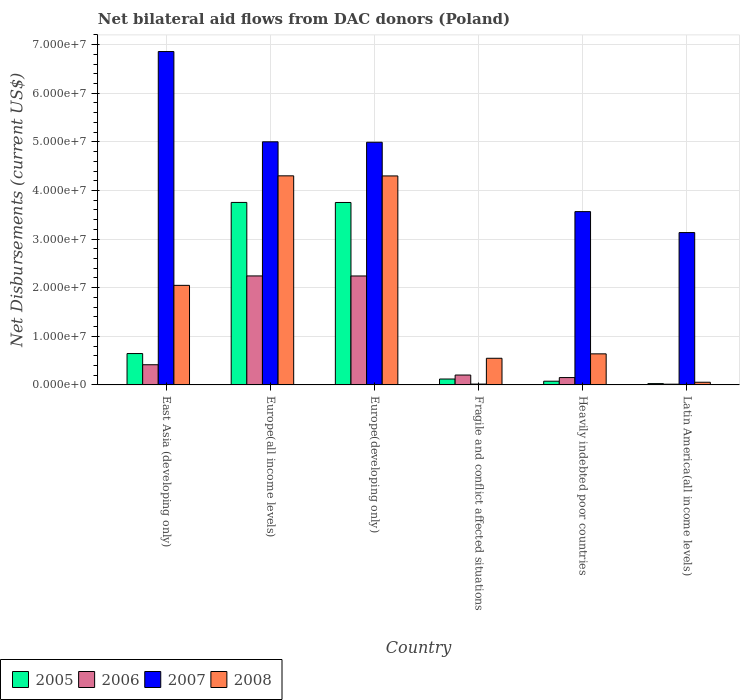How many bars are there on the 3rd tick from the left?
Offer a terse response. 4. What is the label of the 4th group of bars from the left?
Your response must be concise. Fragile and conflict affected situations. What is the net bilateral aid flows in 2006 in Europe(all income levels)?
Provide a succinct answer. 2.24e+07. Across all countries, what is the maximum net bilateral aid flows in 2005?
Your response must be concise. 3.75e+07. In which country was the net bilateral aid flows in 2008 maximum?
Keep it short and to the point. Europe(all income levels). In which country was the net bilateral aid flows in 2007 minimum?
Make the answer very short. Fragile and conflict affected situations. What is the total net bilateral aid flows in 2007 in the graph?
Provide a succinct answer. 2.36e+08. What is the difference between the net bilateral aid flows in 2006 in East Asia (developing only) and the net bilateral aid flows in 2005 in Europe(all income levels)?
Give a very brief answer. -3.34e+07. What is the average net bilateral aid flows in 2008 per country?
Your answer should be very brief. 1.98e+07. What is the ratio of the net bilateral aid flows in 2006 in Heavily indebted poor countries to that in Latin America(all income levels)?
Make the answer very short. 10.07. What is the difference between the highest and the second highest net bilateral aid flows in 2005?
Provide a short and direct response. 3.11e+07. What is the difference between the highest and the lowest net bilateral aid flows in 2006?
Your answer should be compact. 2.23e+07. In how many countries, is the net bilateral aid flows in 2008 greater than the average net bilateral aid flows in 2008 taken over all countries?
Make the answer very short. 3. Is the sum of the net bilateral aid flows in 2008 in Europe(all income levels) and Fragile and conflict affected situations greater than the maximum net bilateral aid flows in 2005 across all countries?
Ensure brevity in your answer.  Yes. What does the 4th bar from the left in Heavily indebted poor countries represents?
Ensure brevity in your answer.  2008. How many bars are there?
Your answer should be compact. 24. Are all the bars in the graph horizontal?
Make the answer very short. No. How many countries are there in the graph?
Keep it short and to the point. 6. What is the difference between two consecutive major ticks on the Y-axis?
Your response must be concise. 1.00e+07. How many legend labels are there?
Give a very brief answer. 4. How are the legend labels stacked?
Make the answer very short. Horizontal. What is the title of the graph?
Provide a succinct answer. Net bilateral aid flows from DAC donors (Poland). Does "1993" appear as one of the legend labels in the graph?
Provide a succinct answer. No. What is the label or title of the X-axis?
Your answer should be very brief. Country. What is the label or title of the Y-axis?
Your answer should be compact. Net Disbursements (current US$). What is the Net Disbursements (current US$) of 2005 in East Asia (developing only)?
Offer a very short reply. 6.45e+06. What is the Net Disbursements (current US$) in 2006 in East Asia (developing only)?
Your answer should be compact. 4.15e+06. What is the Net Disbursements (current US$) of 2007 in East Asia (developing only)?
Your response must be concise. 6.86e+07. What is the Net Disbursements (current US$) of 2008 in East Asia (developing only)?
Your answer should be very brief. 2.05e+07. What is the Net Disbursements (current US$) of 2005 in Europe(all income levels)?
Your answer should be compact. 3.75e+07. What is the Net Disbursements (current US$) in 2006 in Europe(all income levels)?
Offer a very short reply. 2.24e+07. What is the Net Disbursements (current US$) of 2007 in Europe(all income levels)?
Provide a short and direct response. 5.00e+07. What is the Net Disbursements (current US$) in 2008 in Europe(all income levels)?
Ensure brevity in your answer.  4.30e+07. What is the Net Disbursements (current US$) of 2005 in Europe(developing only)?
Make the answer very short. 3.75e+07. What is the Net Disbursements (current US$) of 2006 in Europe(developing only)?
Ensure brevity in your answer.  2.24e+07. What is the Net Disbursements (current US$) in 2007 in Europe(developing only)?
Your answer should be very brief. 4.99e+07. What is the Net Disbursements (current US$) of 2008 in Europe(developing only)?
Your answer should be compact. 4.30e+07. What is the Net Disbursements (current US$) in 2005 in Fragile and conflict affected situations?
Give a very brief answer. 1.21e+06. What is the Net Disbursements (current US$) in 2006 in Fragile and conflict affected situations?
Offer a terse response. 2.03e+06. What is the Net Disbursements (current US$) of 2008 in Fragile and conflict affected situations?
Offer a terse response. 5.48e+06. What is the Net Disbursements (current US$) in 2005 in Heavily indebted poor countries?
Keep it short and to the point. 7.60e+05. What is the Net Disbursements (current US$) in 2006 in Heavily indebted poor countries?
Give a very brief answer. 1.51e+06. What is the Net Disbursements (current US$) in 2007 in Heavily indebted poor countries?
Keep it short and to the point. 3.56e+07. What is the Net Disbursements (current US$) in 2008 in Heavily indebted poor countries?
Make the answer very short. 6.39e+06. What is the Net Disbursements (current US$) in 2007 in Latin America(all income levels)?
Your answer should be compact. 3.13e+07. Across all countries, what is the maximum Net Disbursements (current US$) of 2005?
Ensure brevity in your answer.  3.75e+07. Across all countries, what is the maximum Net Disbursements (current US$) of 2006?
Offer a terse response. 2.24e+07. Across all countries, what is the maximum Net Disbursements (current US$) of 2007?
Offer a very short reply. 6.86e+07. Across all countries, what is the maximum Net Disbursements (current US$) in 2008?
Provide a succinct answer. 4.30e+07. Across all countries, what is the minimum Net Disbursements (current US$) of 2005?
Provide a succinct answer. 2.70e+05. Across all countries, what is the minimum Net Disbursements (current US$) of 2008?
Offer a very short reply. 5.50e+05. What is the total Net Disbursements (current US$) in 2005 in the graph?
Offer a terse response. 8.38e+07. What is the total Net Disbursements (current US$) in 2006 in the graph?
Your response must be concise. 5.27e+07. What is the total Net Disbursements (current US$) of 2007 in the graph?
Your answer should be very brief. 2.36e+08. What is the total Net Disbursements (current US$) in 2008 in the graph?
Offer a terse response. 1.19e+08. What is the difference between the Net Disbursements (current US$) of 2005 in East Asia (developing only) and that in Europe(all income levels)?
Your answer should be very brief. -3.11e+07. What is the difference between the Net Disbursements (current US$) of 2006 in East Asia (developing only) and that in Europe(all income levels)?
Your answer should be compact. -1.83e+07. What is the difference between the Net Disbursements (current US$) in 2007 in East Asia (developing only) and that in Europe(all income levels)?
Provide a succinct answer. 1.86e+07. What is the difference between the Net Disbursements (current US$) in 2008 in East Asia (developing only) and that in Europe(all income levels)?
Give a very brief answer. -2.25e+07. What is the difference between the Net Disbursements (current US$) in 2005 in East Asia (developing only) and that in Europe(developing only)?
Your answer should be compact. -3.11e+07. What is the difference between the Net Disbursements (current US$) in 2006 in East Asia (developing only) and that in Europe(developing only)?
Keep it short and to the point. -1.83e+07. What is the difference between the Net Disbursements (current US$) in 2007 in East Asia (developing only) and that in Europe(developing only)?
Your answer should be very brief. 1.87e+07. What is the difference between the Net Disbursements (current US$) in 2008 in East Asia (developing only) and that in Europe(developing only)?
Make the answer very short. -2.25e+07. What is the difference between the Net Disbursements (current US$) in 2005 in East Asia (developing only) and that in Fragile and conflict affected situations?
Provide a succinct answer. 5.24e+06. What is the difference between the Net Disbursements (current US$) in 2006 in East Asia (developing only) and that in Fragile and conflict affected situations?
Ensure brevity in your answer.  2.12e+06. What is the difference between the Net Disbursements (current US$) of 2007 in East Asia (developing only) and that in Fragile and conflict affected situations?
Keep it short and to the point. 6.84e+07. What is the difference between the Net Disbursements (current US$) in 2008 in East Asia (developing only) and that in Fragile and conflict affected situations?
Your answer should be very brief. 1.50e+07. What is the difference between the Net Disbursements (current US$) in 2005 in East Asia (developing only) and that in Heavily indebted poor countries?
Provide a short and direct response. 5.69e+06. What is the difference between the Net Disbursements (current US$) in 2006 in East Asia (developing only) and that in Heavily indebted poor countries?
Give a very brief answer. 2.64e+06. What is the difference between the Net Disbursements (current US$) in 2007 in East Asia (developing only) and that in Heavily indebted poor countries?
Your answer should be compact. 3.29e+07. What is the difference between the Net Disbursements (current US$) in 2008 in East Asia (developing only) and that in Heavily indebted poor countries?
Keep it short and to the point. 1.41e+07. What is the difference between the Net Disbursements (current US$) of 2005 in East Asia (developing only) and that in Latin America(all income levels)?
Provide a short and direct response. 6.18e+06. What is the difference between the Net Disbursements (current US$) of 2007 in East Asia (developing only) and that in Latin America(all income levels)?
Ensure brevity in your answer.  3.72e+07. What is the difference between the Net Disbursements (current US$) of 2008 in East Asia (developing only) and that in Latin America(all income levels)?
Offer a terse response. 1.99e+07. What is the difference between the Net Disbursements (current US$) in 2006 in Europe(all income levels) and that in Europe(developing only)?
Ensure brevity in your answer.  10000. What is the difference between the Net Disbursements (current US$) of 2007 in Europe(all income levels) and that in Europe(developing only)?
Your answer should be compact. 9.00e+04. What is the difference between the Net Disbursements (current US$) of 2005 in Europe(all income levels) and that in Fragile and conflict affected situations?
Ensure brevity in your answer.  3.63e+07. What is the difference between the Net Disbursements (current US$) in 2006 in Europe(all income levels) and that in Fragile and conflict affected situations?
Your answer should be very brief. 2.04e+07. What is the difference between the Net Disbursements (current US$) in 2007 in Europe(all income levels) and that in Fragile and conflict affected situations?
Your answer should be compact. 4.98e+07. What is the difference between the Net Disbursements (current US$) in 2008 in Europe(all income levels) and that in Fragile and conflict affected situations?
Your answer should be compact. 3.75e+07. What is the difference between the Net Disbursements (current US$) of 2005 in Europe(all income levels) and that in Heavily indebted poor countries?
Offer a very short reply. 3.68e+07. What is the difference between the Net Disbursements (current US$) in 2006 in Europe(all income levels) and that in Heavily indebted poor countries?
Ensure brevity in your answer.  2.09e+07. What is the difference between the Net Disbursements (current US$) of 2007 in Europe(all income levels) and that in Heavily indebted poor countries?
Provide a succinct answer. 1.44e+07. What is the difference between the Net Disbursements (current US$) in 2008 in Europe(all income levels) and that in Heavily indebted poor countries?
Make the answer very short. 3.66e+07. What is the difference between the Net Disbursements (current US$) of 2005 in Europe(all income levels) and that in Latin America(all income levels)?
Keep it short and to the point. 3.73e+07. What is the difference between the Net Disbursements (current US$) in 2006 in Europe(all income levels) and that in Latin America(all income levels)?
Your response must be concise. 2.23e+07. What is the difference between the Net Disbursements (current US$) of 2007 in Europe(all income levels) and that in Latin America(all income levels)?
Give a very brief answer. 1.87e+07. What is the difference between the Net Disbursements (current US$) of 2008 in Europe(all income levels) and that in Latin America(all income levels)?
Ensure brevity in your answer.  4.25e+07. What is the difference between the Net Disbursements (current US$) of 2005 in Europe(developing only) and that in Fragile and conflict affected situations?
Provide a succinct answer. 3.63e+07. What is the difference between the Net Disbursements (current US$) in 2006 in Europe(developing only) and that in Fragile and conflict affected situations?
Your answer should be very brief. 2.04e+07. What is the difference between the Net Disbursements (current US$) of 2007 in Europe(developing only) and that in Fragile and conflict affected situations?
Provide a short and direct response. 4.98e+07. What is the difference between the Net Disbursements (current US$) of 2008 in Europe(developing only) and that in Fragile and conflict affected situations?
Provide a short and direct response. 3.75e+07. What is the difference between the Net Disbursements (current US$) of 2005 in Europe(developing only) and that in Heavily indebted poor countries?
Your answer should be compact. 3.68e+07. What is the difference between the Net Disbursements (current US$) in 2006 in Europe(developing only) and that in Heavily indebted poor countries?
Your response must be concise. 2.09e+07. What is the difference between the Net Disbursements (current US$) of 2007 in Europe(developing only) and that in Heavily indebted poor countries?
Your answer should be very brief. 1.43e+07. What is the difference between the Net Disbursements (current US$) in 2008 in Europe(developing only) and that in Heavily indebted poor countries?
Ensure brevity in your answer.  3.66e+07. What is the difference between the Net Disbursements (current US$) of 2005 in Europe(developing only) and that in Latin America(all income levels)?
Keep it short and to the point. 3.73e+07. What is the difference between the Net Disbursements (current US$) of 2006 in Europe(developing only) and that in Latin America(all income levels)?
Offer a terse response. 2.23e+07. What is the difference between the Net Disbursements (current US$) of 2007 in Europe(developing only) and that in Latin America(all income levels)?
Offer a very short reply. 1.86e+07. What is the difference between the Net Disbursements (current US$) in 2008 in Europe(developing only) and that in Latin America(all income levels)?
Keep it short and to the point. 4.24e+07. What is the difference between the Net Disbursements (current US$) of 2005 in Fragile and conflict affected situations and that in Heavily indebted poor countries?
Offer a very short reply. 4.50e+05. What is the difference between the Net Disbursements (current US$) of 2006 in Fragile and conflict affected situations and that in Heavily indebted poor countries?
Your response must be concise. 5.20e+05. What is the difference between the Net Disbursements (current US$) of 2007 in Fragile and conflict affected situations and that in Heavily indebted poor countries?
Your answer should be very brief. -3.55e+07. What is the difference between the Net Disbursements (current US$) of 2008 in Fragile and conflict affected situations and that in Heavily indebted poor countries?
Offer a terse response. -9.10e+05. What is the difference between the Net Disbursements (current US$) in 2005 in Fragile and conflict affected situations and that in Latin America(all income levels)?
Provide a succinct answer. 9.40e+05. What is the difference between the Net Disbursements (current US$) of 2006 in Fragile and conflict affected situations and that in Latin America(all income levels)?
Your response must be concise. 1.88e+06. What is the difference between the Net Disbursements (current US$) of 2007 in Fragile and conflict affected situations and that in Latin America(all income levels)?
Make the answer very short. -3.12e+07. What is the difference between the Net Disbursements (current US$) in 2008 in Fragile and conflict affected situations and that in Latin America(all income levels)?
Make the answer very short. 4.93e+06. What is the difference between the Net Disbursements (current US$) of 2005 in Heavily indebted poor countries and that in Latin America(all income levels)?
Offer a terse response. 4.90e+05. What is the difference between the Net Disbursements (current US$) of 2006 in Heavily indebted poor countries and that in Latin America(all income levels)?
Provide a succinct answer. 1.36e+06. What is the difference between the Net Disbursements (current US$) of 2007 in Heavily indebted poor countries and that in Latin America(all income levels)?
Offer a terse response. 4.31e+06. What is the difference between the Net Disbursements (current US$) of 2008 in Heavily indebted poor countries and that in Latin America(all income levels)?
Give a very brief answer. 5.84e+06. What is the difference between the Net Disbursements (current US$) in 2005 in East Asia (developing only) and the Net Disbursements (current US$) in 2006 in Europe(all income levels)?
Your answer should be very brief. -1.60e+07. What is the difference between the Net Disbursements (current US$) in 2005 in East Asia (developing only) and the Net Disbursements (current US$) in 2007 in Europe(all income levels)?
Keep it short and to the point. -4.36e+07. What is the difference between the Net Disbursements (current US$) of 2005 in East Asia (developing only) and the Net Disbursements (current US$) of 2008 in Europe(all income levels)?
Your answer should be compact. -3.66e+07. What is the difference between the Net Disbursements (current US$) of 2006 in East Asia (developing only) and the Net Disbursements (current US$) of 2007 in Europe(all income levels)?
Offer a terse response. -4.59e+07. What is the difference between the Net Disbursements (current US$) of 2006 in East Asia (developing only) and the Net Disbursements (current US$) of 2008 in Europe(all income levels)?
Your answer should be very brief. -3.89e+07. What is the difference between the Net Disbursements (current US$) in 2007 in East Asia (developing only) and the Net Disbursements (current US$) in 2008 in Europe(all income levels)?
Offer a very short reply. 2.56e+07. What is the difference between the Net Disbursements (current US$) of 2005 in East Asia (developing only) and the Net Disbursements (current US$) of 2006 in Europe(developing only)?
Offer a very short reply. -1.60e+07. What is the difference between the Net Disbursements (current US$) in 2005 in East Asia (developing only) and the Net Disbursements (current US$) in 2007 in Europe(developing only)?
Your response must be concise. -4.35e+07. What is the difference between the Net Disbursements (current US$) in 2005 in East Asia (developing only) and the Net Disbursements (current US$) in 2008 in Europe(developing only)?
Give a very brief answer. -3.65e+07. What is the difference between the Net Disbursements (current US$) in 2006 in East Asia (developing only) and the Net Disbursements (current US$) in 2007 in Europe(developing only)?
Your response must be concise. -4.58e+07. What is the difference between the Net Disbursements (current US$) of 2006 in East Asia (developing only) and the Net Disbursements (current US$) of 2008 in Europe(developing only)?
Your response must be concise. -3.88e+07. What is the difference between the Net Disbursements (current US$) of 2007 in East Asia (developing only) and the Net Disbursements (current US$) of 2008 in Europe(developing only)?
Your answer should be compact. 2.56e+07. What is the difference between the Net Disbursements (current US$) of 2005 in East Asia (developing only) and the Net Disbursements (current US$) of 2006 in Fragile and conflict affected situations?
Ensure brevity in your answer.  4.42e+06. What is the difference between the Net Disbursements (current US$) in 2005 in East Asia (developing only) and the Net Disbursements (current US$) in 2007 in Fragile and conflict affected situations?
Your response must be concise. 6.28e+06. What is the difference between the Net Disbursements (current US$) in 2005 in East Asia (developing only) and the Net Disbursements (current US$) in 2008 in Fragile and conflict affected situations?
Provide a succinct answer. 9.70e+05. What is the difference between the Net Disbursements (current US$) of 2006 in East Asia (developing only) and the Net Disbursements (current US$) of 2007 in Fragile and conflict affected situations?
Provide a short and direct response. 3.98e+06. What is the difference between the Net Disbursements (current US$) in 2006 in East Asia (developing only) and the Net Disbursements (current US$) in 2008 in Fragile and conflict affected situations?
Give a very brief answer. -1.33e+06. What is the difference between the Net Disbursements (current US$) in 2007 in East Asia (developing only) and the Net Disbursements (current US$) in 2008 in Fragile and conflict affected situations?
Offer a very short reply. 6.31e+07. What is the difference between the Net Disbursements (current US$) of 2005 in East Asia (developing only) and the Net Disbursements (current US$) of 2006 in Heavily indebted poor countries?
Provide a short and direct response. 4.94e+06. What is the difference between the Net Disbursements (current US$) in 2005 in East Asia (developing only) and the Net Disbursements (current US$) in 2007 in Heavily indebted poor countries?
Ensure brevity in your answer.  -2.92e+07. What is the difference between the Net Disbursements (current US$) of 2006 in East Asia (developing only) and the Net Disbursements (current US$) of 2007 in Heavily indebted poor countries?
Keep it short and to the point. -3.15e+07. What is the difference between the Net Disbursements (current US$) of 2006 in East Asia (developing only) and the Net Disbursements (current US$) of 2008 in Heavily indebted poor countries?
Make the answer very short. -2.24e+06. What is the difference between the Net Disbursements (current US$) of 2007 in East Asia (developing only) and the Net Disbursements (current US$) of 2008 in Heavily indebted poor countries?
Offer a terse response. 6.22e+07. What is the difference between the Net Disbursements (current US$) in 2005 in East Asia (developing only) and the Net Disbursements (current US$) in 2006 in Latin America(all income levels)?
Offer a very short reply. 6.30e+06. What is the difference between the Net Disbursements (current US$) of 2005 in East Asia (developing only) and the Net Disbursements (current US$) of 2007 in Latin America(all income levels)?
Give a very brief answer. -2.49e+07. What is the difference between the Net Disbursements (current US$) of 2005 in East Asia (developing only) and the Net Disbursements (current US$) of 2008 in Latin America(all income levels)?
Make the answer very short. 5.90e+06. What is the difference between the Net Disbursements (current US$) of 2006 in East Asia (developing only) and the Net Disbursements (current US$) of 2007 in Latin America(all income levels)?
Ensure brevity in your answer.  -2.72e+07. What is the difference between the Net Disbursements (current US$) of 2006 in East Asia (developing only) and the Net Disbursements (current US$) of 2008 in Latin America(all income levels)?
Provide a succinct answer. 3.60e+06. What is the difference between the Net Disbursements (current US$) of 2007 in East Asia (developing only) and the Net Disbursements (current US$) of 2008 in Latin America(all income levels)?
Your answer should be very brief. 6.80e+07. What is the difference between the Net Disbursements (current US$) in 2005 in Europe(all income levels) and the Net Disbursements (current US$) in 2006 in Europe(developing only)?
Keep it short and to the point. 1.51e+07. What is the difference between the Net Disbursements (current US$) in 2005 in Europe(all income levels) and the Net Disbursements (current US$) in 2007 in Europe(developing only)?
Keep it short and to the point. -1.24e+07. What is the difference between the Net Disbursements (current US$) of 2005 in Europe(all income levels) and the Net Disbursements (current US$) of 2008 in Europe(developing only)?
Provide a short and direct response. -5.45e+06. What is the difference between the Net Disbursements (current US$) of 2006 in Europe(all income levels) and the Net Disbursements (current US$) of 2007 in Europe(developing only)?
Offer a terse response. -2.75e+07. What is the difference between the Net Disbursements (current US$) in 2006 in Europe(all income levels) and the Net Disbursements (current US$) in 2008 in Europe(developing only)?
Your answer should be very brief. -2.06e+07. What is the difference between the Net Disbursements (current US$) of 2007 in Europe(all income levels) and the Net Disbursements (current US$) of 2008 in Europe(developing only)?
Your answer should be very brief. 7.02e+06. What is the difference between the Net Disbursements (current US$) in 2005 in Europe(all income levels) and the Net Disbursements (current US$) in 2006 in Fragile and conflict affected situations?
Offer a very short reply. 3.55e+07. What is the difference between the Net Disbursements (current US$) of 2005 in Europe(all income levels) and the Net Disbursements (current US$) of 2007 in Fragile and conflict affected situations?
Your answer should be very brief. 3.74e+07. What is the difference between the Net Disbursements (current US$) in 2005 in Europe(all income levels) and the Net Disbursements (current US$) in 2008 in Fragile and conflict affected situations?
Your response must be concise. 3.21e+07. What is the difference between the Net Disbursements (current US$) in 2006 in Europe(all income levels) and the Net Disbursements (current US$) in 2007 in Fragile and conflict affected situations?
Provide a succinct answer. 2.22e+07. What is the difference between the Net Disbursements (current US$) of 2006 in Europe(all income levels) and the Net Disbursements (current US$) of 2008 in Fragile and conflict affected situations?
Offer a terse response. 1.69e+07. What is the difference between the Net Disbursements (current US$) of 2007 in Europe(all income levels) and the Net Disbursements (current US$) of 2008 in Fragile and conflict affected situations?
Your answer should be very brief. 4.45e+07. What is the difference between the Net Disbursements (current US$) of 2005 in Europe(all income levels) and the Net Disbursements (current US$) of 2006 in Heavily indebted poor countries?
Provide a succinct answer. 3.60e+07. What is the difference between the Net Disbursements (current US$) of 2005 in Europe(all income levels) and the Net Disbursements (current US$) of 2007 in Heavily indebted poor countries?
Offer a terse response. 1.89e+06. What is the difference between the Net Disbursements (current US$) in 2005 in Europe(all income levels) and the Net Disbursements (current US$) in 2008 in Heavily indebted poor countries?
Your answer should be compact. 3.12e+07. What is the difference between the Net Disbursements (current US$) in 2006 in Europe(all income levels) and the Net Disbursements (current US$) in 2007 in Heavily indebted poor countries?
Your response must be concise. -1.32e+07. What is the difference between the Net Disbursements (current US$) of 2006 in Europe(all income levels) and the Net Disbursements (current US$) of 2008 in Heavily indebted poor countries?
Your answer should be compact. 1.60e+07. What is the difference between the Net Disbursements (current US$) of 2007 in Europe(all income levels) and the Net Disbursements (current US$) of 2008 in Heavily indebted poor countries?
Make the answer very short. 4.36e+07. What is the difference between the Net Disbursements (current US$) of 2005 in Europe(all income levels) and the Net Disbursements (current US$) of 2006 in Latin America(all income levels)?
Your response must be concise. 3.74e+07. What is the difference between the Net Disbursements (current US$) of 2005 in Europe(all income levels) and the Net Disbursements (current US$) of 2007 in Latin America(all income levels)?
Keep it short and to the point. 6.20e+06. What is the difference between the Net Disbursements (current US$) of 2005 in Europe(all income levels) and the Net Disbursements (current US$) of 2008 in Latin America(all income levels)?
Your response must be concise. 3.70e+07. What is the difference between the Net Disbursements (current US$) of 2006 in Europe(all income levels) and the Net Disbursements (current US$) of 2007 in Latin America(all income levels)?
Give a very brief answer. -8.92e+06. What is the difference between the Net Disbursements (current US$) of 2006 in Europe(all income levels) and the Net Disbursements (current US$) of 2008 in Latin America(all income levels)?
Give a very brief answer. 2.19e+07. What is the difference between the Net Disbursements (current US$) of 2007 in Europe(all income levels) and the Net Disbursements (current US$) of 2008 in Latin America(all income levels)?
Ensure brevity in your answer.  4.95e+07. What is the difference between the Net Disbursements (current US$) in 2005 in Europe(developing only) and the Net Disbursements (current US$) in 2006 in Fragile and conflict affected situations?
Make the answer very short. 3.55e+07. What is the difference between the Net Disbursements (current US$) in 2005 in Europe(developing only) and the Net Disbursements (current US$) in 2007 in Fragile and conflict affected situations?
Your answer should be very brief. 3.74e+07. What is the difference between the Net Disbursements (current US$) in 2005 in Europe(developing only) and the Net Disbursements (current US$) in 2008 in Fragile and conflict affected situations?
Make the answer very short. 3.20e+07. What is the difference between the Net Disbursements (current US$) of 2006 in Europe(developing only) and the Net Disbursements (current US$) of 2007 in Fragile and conflict affected situations?
Provide a short and direct response. 2.22e+07. What is the difference between the Net Disbursements (current US$) of 2006 in Europe(developing only) and the Net Disbursements (current US$) of 2008 in Fragile and conflict affected situations?
Make the answer very short. 1.69e+07. What is the difference between the Net Disbursements (current US$) of 2007 in Europe(developing only) and the Net Disbursements (current US$) of 2008 in Fragile and conflict affected situations?
Make the answer very short. 4.44e+07. What is the difference between the Net Disbursements (current US$) of 2005 in Europe(developing only) and the Net Disbursements (current US$) of 2006 in Heavily indebted poor countries?
Make the answer very short. 3.60e+07. What is the difference between the Net Disbursements (current US$) of 2005 in Europe(developing only) and the Net Disbursements (current US$) of 2007 in Heavily indebted poor countries?
Provide a succinct answer. 1.88e+06. What is the difference between the Net Disbursements (current US$) of 2005 in Europe(developing only) and the Net Disbursements (current US$) of 2008 in Heavily indebted poor countries?
Offer a very short reply. 3.11e+07. What is the difference between the Net Disbursements (current US$) in 2006 in Europe(developing only) and the Net Disbursements (current US$) in 2007 in Heavily indebted poor countries?
Your answer should be very brief. -1.32e+07. What is the difference between the Net Disbursements (current US$) of 2006 in Europe(developing only) and the Net Disbursements (current US$) of 2008 in Heavily indebted poor countries?
Make the answer very short. 1.60e+07. What is the difference between the Net Disbursements (current US$) in 2007 in Europe(developing only) and the Net Disbursements (current US$) in 2008 in Heavily indebted poor countries?
Keep it short and to the point. 4.35e+07. What is the difference between the Net Disbursements (current US$) in 2005 in Europe(developing only) and the Net Disbursements (current US$) in 2006 in Latin America(all income levels)?
Offer a terse response. 3.74e+07. What is the difference between the Net Disbursements (current US$) in 2005 in Europe(developing only) and the Net Disbursements (current US$) in 2007 in Latin America(all income levels)?
Provide a succinct answer. 6.19e+06. What is the difference between the Net Disbursements (current US$) in 2005 in Europe(developing only) and the Net Disbursements (current US$) in 2008 in Latin America(all income levels)?
Ensure brevity in your answer.  3.70e+07. What is the difference between the Net Disbursements (current US$) in 2006 in Europe(developing only) and the Net Disbursements (current US$) in 2007 in Latin America(all income levels)?
Your answer should be compact. -8.93e+06. What is the difference between the Net Disbursements (current US$) of 2006 in Europe(developing only) and the Net Disbursements (current US$) of 2008 in Latin America(all income levels)?
Make the answer very short. 2.19e+07. What is the difference between the Net Disbursements (current US$) of 2007 in Europe(developing only) and the Net Disbursements (current US$) of 2008 in Latin America(all income levels)?
Your answer should be compact. 4.94e+07. What is the difference between the Net Disbursements (current US$) in 2005 in Fragile and conflict affected situations and the Net Disbursements (current US$) in 2007 in Heavily indebted poor countries?
Make the answer very short. -3.44e+07. What is the difference between the Net Disbursements (current US$) of 2005 in Fragile and conflict affected situations and the Net Disbursements (current US$) of 2008 in Heavily indebted poor countries?
Your response must be concise. -5.18e+06. What is the difference between the Net Disbursements (current US$) of 2006 in Fragile and conflict affected situations and the Net Disbursements (current US$) of 2007 in Heavily indebted poor countries?
Make the answer very short. -3.36e+07. What is the difference between the Net Disbursements (current US$) in 2006 in Fragile and conflict affected situations and the Net Disbursements (current US$) in 2008 in Heavily indebted poor countries?
Your answer should be compact. -4.36e+06. What is the difference between the Net Disbursements (current US$) of 2007 in Fragile and conflict affected situations and the Net Disbursements (current US$) of 2008 in Heavily indebted poor countries?
Your answer should be compact. -6.22e+06. What is the difference between the Net Disbursements (current US$) of 2005 in Fragile and conflict affected situations and the Net Disbursements (current US$) of 2006 in Latin America(all income levels)?
Keep it short and to the point. 1.06e+06. What is the difference between the Net Disbursements (current US$) of 2005 in Fragile and conflict affected situations and the Net Disbursements (current US$) of 2007 in Latin America(all income levels)?
Offer a terse response. -3.01e+07. What is the difference between the Net Disbursements (current US$) in 2006 in Fragile and conflict affected situations and the Net Disbursements (current US$) in 2007 in Latin America(all income levels)?
Ensure brevity in your answer.  -2.93e+07. What is the difference between the Net Disbursements (current US$) of 2006 in Fragile and conflict affected situations and the Net Disbursements (current US$) of 2008 in Latin America(all income levels)?
Keep it short and to the point. 1.48e+06. What is the difference between the Net Disbursements (current US$) in 2007 in Fragile and conflict affected situations and the Net Disbursements (current US$) in 2008 in Latin America(all income levels)?
Offer a very short reply. -3.80e+05. What is the difference between the Net Disbursements (current US$) of 2005 in Heavily indebted poor countries and the Net Disbursements (current US$) of 2006 in Latin America(all income levels)?
Offer a terse response. 6.10e+05. What is the difference between the Net Disbursements (current US$) in 2005 in Heavily indebted poor countries and the Net Disbursements (current US$) in 2007 in Latin America(all income levels)?
Provide a succinct answer. -3.06e+07. What is the difference between the Net Disbursements (current US$) of 2005 in Heavily indebted poor countries and the Net Disbursements (current US$) of 2008 in Latin America(all income levels)?
Your answer should be very brief. 2.10e+05. What is the difference between the Net Disbursements (current US$) of 2006 in Heavily indebted poor countries and the Net Disbursements (current US$) of 2007 in Latin America(all income levels)?
Offer a very short reply. -2.98e+07. What is the difference between the Net Disbursements (current US$) in 2006 in Heavily indebted poor countries and the Net Disbursements (current US$) in 2008 in Latin America(all income levels)?
Ensure brevity in your answer.  9.60e+05. What is the difference between the Net Disbursements (current US$) in 2007 in Heavily indebted poor countries and the Net Disbursements (current US$) in 2008 in Latin America(all income levels)?
Provide a short and direct response. 3.51e+07. What is the average Net Disbursements (current US$) in 2005 per country?
Give a very brief answer. 1.40e+07. What is the average Net Disbursements (current US$) in 2006 per country?
Give a very brief answer. 8.78e+06. What is the average Net Disbursements (current US$) in 2007 per country?
Offer a terse response. 3.93e+07. What is the average Net Disbursements (current US$) of 2008 per country?
Your answer should be very brief. 1.98e+07. What is the difference between the Net Disbursements (current US$) of 2005 and Net Disbursements (current US$) of 2006 in East Asia (developing only)?
Keep it short and to the point. 2.30e+06. What is the difference between the Net Disbursements (current US$) in 2005 and Net Disbursements (current US$) in 2007 in East Asia (developing only)?
Your response must be concise. -6.21e+07. What is the difference between the Net Disbursements (current US$) in 2005 and Net Disbursements (current US$) in 2008 in East Asia (developing only)?
Ensure brevity in your answer.  -1.40e+07. What is the difference between the Net Disbursements (current US$) of 2006 and Net Disbursements (current US$) of 2007 in East Asia (developing only)?
Offer a very short reply. -6.44e+07. What is the difference between the Net Disbursements (current US$) of 2006 and Net Disbursements (current US$) of 2008 in East Asia (developing only)?
Provide a succinct answer. -1.63e+07. What is the difference between the Net Disbursements (current US$) of 2007 and Net Disbursements (current US$) of 2008 in East Asia (developing only)?
Offer a terse response. 4.81e+07. What is the difference between the Net Disbursements (current US$) of 2005 and Net Disbursements (current US$) of 2006 in Europe(all income levels)?
Offer a very short reply. 1.51e+07. What is the difference between the Net Disbursements (current US$) of 2005 and Net Disbursements (current US$) of 2007 in Europe(all income levels)?
Your response must be concise. -1.25e+07. What is the difference between the Net Disbursements (current US$) of 2005 and Net Disbursements (current US$) of 2008 in Europe(all income levels)?
Provide a short and direct response. -5.47e+06. What is the difference between the Net Disbursements (current US$) of 2006 and Net Disbursements (current US$) of 2007 in Europe(all income levels)?
Provide a succinct answer. -2.76e+07. What is the difference between the Net Disbursements (current US$) of 2006 and Net Disbursements (current US$) of 2008 in Europe(all income levels)?
Make the answer very short. -2.06e+07. What is the difference between the Net Disbursements (current US$) of 2007 and Net Disbursements (current US$) of 2008 in Europe(all income levels)?
Your answer should be very brief. 7.00e+06. What is the difference between the Net Disbursements (current US$) in 2005 and Net Disbursements (current US$) in 2006 in Europe(developing only)?
Your response must be concise. 1.51e+07. What is the difference between the Net Disbursements (current US$) of 2005 and Net Disbursements (current US$) of 2007 in Europe(developing only)?
Give a very brief answer. -1.24e+07. What is the difference between the Net Disbursements (current US$) of 2005 and Net Disbursements (current US$) of 2008 in Europe(developing only)?
Give a very brief answer. -5.46e+06. What is the difference between the Net Disbursements (current US$) of 2006 and Net Disbursements (current US$) of 2007 in Europe(developing only)?
Your answer should be compact. -2.75e+07. What is the difference between the Net Disbursements (current US$) in 2006 and Net Disbursements (current US$) in 2008 in Europe(developing only)?
Give a very brief answer. -2.06e+07. What is the difference between the Net Disbursements (current US$) in 2007 and Net Disbursements (current US$) in 2008 in Europe(developing only)?
Provide a short and direct response. 6.93e+06. What is the difference between the Net Disbursements (current US$) in 2005 and Net Disbursements (current US$) in 2006 in Fragile and conflict affected situations?
Provide a short and direct response. -8.20e+05. What is the difference between the Net Disbursements (current US$) in 2005 and Net Disbursements (current US$) in 2007 in Fragile and conflict affected situations?
Offer a very short reply. 1.04e+06. What is the difference between the Net Disbursements (current US$) of 2005 and Net Disbursements (current US$) of 2008 in Fragile and conflict affected situations?
Offer a terse response. -4.27e+06. What is the difference between the Net Disbursements (current US$) of 2006 and Net Disbursements (current US$) of 2007 in Fragile and conflict affected situations?
Offer a terse response. 1.86e+06. What is the difference between the Net Disbursements (current US$) of 2006 and Net Disbursements (current US$) of 2008 in Fragile and conflict affected situations?
Make the answer very short. -3.45e+06. What is the difference between the Net Disbursements (current US$) of 2007 and Net Disbursements (current US$) of 2008 in Fragile and conflict affected situations?
Your answer should be very brief. -5.31e+06. What is the difference between the Net Disbursements (current US$) of 2005 and Net Disbursements (current US$) of 2006 in Heavily indebted poor countries?
Your answer should be very brief. -7.50e+05. What is the difference between the Net Disbursements (current US$) of 2005 and Net Disbursements (current US$) of 2007 in Heavily indebted poor countries?
Give a very brief answer. -3.49e+07. What is the difference between the Net Disbursements (current US$) of 2005 and Net Disbursements (current US$) of 2008 in Heavily indebted poor countries?
Offer a terse response. -5.63e+06. What is the difference between the Net Disbursements (current US$) of 2006 and Net Disbursements (current US$) of 2007 in Heavily indebted poor countries?
Offer a very short reply. -3.41e+07. What is the difference between the Net Disbursements (current US$) of 2006 and Net Disbursements (current US$) of 2008 in Heavily indebted poor countries?
Your answer should be compact. -4.88e+06. What is the difference between the Net Disbursements (current US$) in 2007 and Net Disbursements (current US$) in 2008 in Heavily indebted poor countries?
Offer a very short reply. 2.93e+07. What is the difference between the Net Disbursements (current US$) of 2005 and Net Disbursements (current US$) of 2006 in Latin America(all income levels)?
Provide a succinct answer. 1.20e+05. What is the difference between the Net Disbursements (current US$) of 2005 and Net Disbursements (current US$) of 2007 in Latin America(all income levels)?
Offer a terse response. -3.11e+07. What is the difference between the Net Disbursements (current US$) in 2005 and Net Disbursements (current US$) in 2008 in Latin America(all income levels)?
Your response must be concise. -2.80e+05. What is the difference between the Net Disbursements (current US$) of 2006 and Net Disbursements (current US$) of 2007 in Latin America(all income levels)?
Your response must be concise. -3.12e+07. What is the difference between the Net Disbursements (current US$) in 2006 and Net Disbursements (current US$) in 2008 in Latin America(all income levels)?
Your response must be concise. -4.00e+05. What is the difference between the Net Disbursements (current US$) of 2007 and Net Disbursements (current US$) of 2008 in Latin America(all income levels)?
Give a very brief answer. 3.08e+07. What is the ratio of the Net Disbursements (current US$) of 2005 in East Asia (developing only) to that in Europe(all income levels)?
Make the answer very short. 0.17. What is the ratio of the Net Disbursements (current US$) in 2006 in East Asia (developing only) to that in Europe(all income levels)?
Provide a succinct answer. 0.19. What is the ratio of the Net Disbursements (current US$) of 2007 in East Asia (developing only) to that in Europe(all income levels)?
Ensure brevity in your answer.  1.37. What is the ratio of the Net Disbursements (current US$) of 2008 in East Asia (developing only) to that in Europe(all income levels)?
Offer a terse response. 0.48. What is the ratio of the Net Disbursements (current US$) of 2005 in East Asia (developing only) to that in Europe(developing only)?
Keep it short and to the point. 0.17. What is the ratio of the Net Disbursements (current US$) of 2006 in East Asia (developing only) to that in Europe(developing only)?
Make the answer very short. 0.19. What is the ratio of the Net Disbursements (current US$) in 2007 in East Asia (developing only) to that in Europe(developing only)?
Offer a terse response. 1.37. What is the ratio of the Net Disbursements (current US$) of 2008 in East Asia (developing only) to that in Europe(developing only)?
Ensure brevity in your answer.  0.48. What is the ratio of the Net Disbursements (current US$) in 2005 in East Asia (developing only) to that in Fragile and conflict affected situations?
Your answer should be compact. 5.33. What is the ratio of the Net Disbursements (current US$) in 2006 in East Asia (developing only) to that in Fragile and conflict affected situations?
Make the answer very short. 2.04. What is the ratio of the Net Disbursements (current US$) in 2007 in East Asia (developing only) to that in Fragile and conflict affected situations?
Your answer should be compact. 403.41. What is the ratio of the Net Disbursements (current US$) in 2008 in East Asia (developing only) to that in Fragile and conflict affected situations?
Your answer should be very brief. 3.74. What is the ratio of the Net Disbursements (current US$) in 2005 in East Asia (developing only) to that in Heavily indebted poor countries?
Your answer should be very brief. 8.49. What is the ratio of the Net Disbursements (current US$) in 2006 in East Asia (developing only) to that in Heavily indebted poor countries?
Provide a short and direct response. 2.75. What is the ratio of the Net Disbursements (current US$) of 2007 in East Asia (developing only) to that in Heavily indebted poor countries?
Provide a succinct answer. 1.92. What is the ratio of the Net Disbursements (current US$) in 2008 in East Asia (developing only) to that in Heavily indebted poor countries?
Keep it short and to the point. 3.21. What is the ratio of the Net Disbursements (current US$) of 2005 in East Asia (developing only) to that in Latin America(all income levels)?
Offer a very short reply. 23.89. What is the ratio of the Net Disbursements (current US$) in 2006 in East Asia (developing only) to that in Latin America(all income levels)?
Your response must be concise. 27.67. What is the ratio of the Net Disbursements (current US$) of 2007 in East Asia (developing only) to that in Latin America(all income levels)?
Offer a terse response. 2.19. What is the ratio of the Net Disbursements (current US$) of 2008 in East Asia (developing only) to that in Latin America(all income levels)?
Make the answer very short. 37.24. What is the ratio of the Net Disbursements (current US$) in 2005 in Europe(all income levels) to that in Europe(developing only)?
Offer a very short reply. 1. What is the ratio of the Net Disbursements (current US$) of 2007 in Europe(all income levels) to that in Europe(developing only)?
Provide a succinct answer. 1. What is the ratio of the Net Disbursements (current US$) of 2008 in Europe(all income levels) to that in Europe(developing only)?
Offer a very short reply. 1. What is the ratio of the Net Disbursements (current US$) in 2005 in Europe(all income levels) to that in Fragile and conflict affected situations?
Your response must be concise. 31.02. What is the ratio of the Net Disbursements (current US$) in 2006 in Europe(all income levels) to that in Fragile and conflict affected situations?
Offer a very short reply. 11.04. What is the ratio of the Net Disbursements (current US$) of 2007 in Europe(all income levels) to that in Fragile and conflict affected situations?
Your response must be concise. 294.18. What is the ratio of the Net Disbursements (current US$) of 2008 in Europe(all income levels) to that in Fragile and conflict affected situations?
Make the answer very short. 7.85. What is the ratio of the Net Disbursements (current US$) of 2005 in Europe(all income levels) to that in Heavily indebted poor countries?
Your answer should be very brief. 49.39. What is the ratio of the Net Disbursements (current US$) in 2006 in Europe(all income levels) to that in Heavily indebted poor countries?
Your answer should be very brief. 14.85. What is the ratio of the Net Disbursements (current US$) in 2007 in Europe(all income levels) to that in Heavily indebted poor countries?
Your answer should be compact. 1.4. What is the ratio of the Net Disbursements (current US$) in 2008 in Europe(all income levels) to that in Heavily indebted poor countries?
Your answer should be very brief. 6.73. What is the ratio of the Net Disbursements (current US$) in 2005 in Europe(all income levels) to that in Latin America(all income levels)?
Keep it short and to the point. 139.04. What is the ratio of the Net Disbursements (current US$) in 2006 in Europe(all income levels) to that in Latin America(all income levels)?
Offer a terse response. 149.47. What is the ratio of the Net Disbursements (current US$) of 2007 in Europe(all income levels) to that in Latin America(all income levels)?
Provide a short and direct response. 1.6. What is the ratio of the Net Disbursements (current US$) in 2008 in Europe(all income levels) to that in Latin America(all income levels)?
Make the answer very short. 78.2. What is the ratio of the Net Disbursements (current US$) of 2005 in Europe(developing only) to that in Fragile and conflict affected situations?
Your response must be concise. 31.02. What is the ratio of the Net Disbursements (current US$) of 2006 in Europe(developing only) to that in Fragile and conflict affected situations?
Offer a very short reply. 11.04. What is the ratio of the Net Disbursements (current US$) of 2007 in Europe(developing only) to that in Fragile and conflict affected situations?
Give a very brief answer. 293.65. What is the ratio of the Net Disbursements (current US$) in 2008 in Europe(developing only) to that in Fragile and conflict affected situations?
Provide a succinct answer. 7.84. What is the ratio of the Net Disbursements (current US$) in 2005 in Europe(developing only) to that in Heavily indebted poor countries?
Give a very brief answer. 49.38. What is the ratio of the Net Disbursements (current US$) in 2006 in Europe(developing only) to that in Heavily indebted poor countries?
Keep it short and to the point. 14.84. What is the ratio of the Net Disbursements (current US$) of 2007 in Europe(developing only) to that in Heavily indebted poor countries?
Give a very brief answer. 1.4. What is the ratio of the Net Disbursements (current US$) of 2008 in Europe(developing only) to that in Heavily indebted poor countries?
Your response must be concise. 6.73. What is the ratio of the Net Disbursements (current US$) of 2005 in Europe(developing only) to that in Latin America(all income levels)?
Keep it short and to the point. 139. What is the ratio of the Net Disbursements (current US$) in 2006 in Europe(developing only) to that in Latin America(all income levels)?
Your answer should be very brief. 149.4. What is the ratio of the Net Disbursements (current US$) in 2007 in Europe(developing only) to that in Latin America(all income levels)?
Offer a terse response. 1.59. What is the ratio of the Net Disbursements (current US$) in 2008 in Europe(developing only) to that in Latin America(all income levels)?
Your response must be concise. 78.16. What is the ratio of the Net Disbursements (current US$) in 2005 in Fragile and conflict affected situations to that in Heavily indebted poor countries?
Your answer should be very brief. 1.59. What is the ratio of the Net Disbursements (current US$) of 2006 in Fragile and conflict affected situations to that in Heavily indebted poor countries?
Your answer should be compact. 1.34. What is the ratio of the Net Disbursements (current US$) in 2007 in Fragile and conflict affected situations to that in Heavily indebted poor countries?
Provide a succinct answer. 0. What is the ratio of the Net Disbursements (current US$) of 2008 in Fragile and conflict affected situations to that in Heavily indebted poor countries?
Give a very brief answer. 0.86. What is the ratio of the Net Disbursements (current US$) of 2005 in Fragile and conflict affected situations to that in Latin America(all income levels)?
Make the answer very short. 4.48. What is the ratio of the Net Disbursements (current US$) in 2006 in Fragile and conflict affected situations to that in Latin America(all income levels)?
Your answer should be very brief. 13.53. What is the ratio of the Net Disbursements (current US$) in 2007 in Fragile and conflict affected situations to that in Latin America(all income levels)?
Keep it short and to the point. 0.01. What is the ratio of the Net Disbursements (current US$) of 2008 in Fragile and conflict affected situations to that in Latin America(all income levels)?
Ensure brevity in your answer.  9.96. What is the ratio of the Net Disbursements (current US$) in 2005 in Heavily indebted poor countries to that in Latin America(all income levels)?
Offer a terse response. 2.81. What is the ratio of the Net Disbursements (current US$) in 2006 in Heavily indebted poor countries to that in Latin America(all income levels)?
Make the answer very short. 10.07. What is the ratio of the Net Disbursements (current US$) of 2007 in Heavily indebted poor countries to that in Latin America(all income levels)?
Your response must be concise. 1.14. What is the ratio of the Net Disbursements (current US$) of 2008 in Heavily indebted poor countries to that in Latin America(all income levels)?
Your answer should be very brief. 11.62. What is the difference between the highest and the second highest Net Disbursements (current US$) in 2006?
Your answer should be compact. 10000. What is the difference between the highest and the second highest Net Disbursements (current US$) of 2007?
Provide a short and direct response. 1.86e+07. What is the difference between the highest and the lowest Net Disbursements (current US$) of 2005?
Keep it short and to the point. 3.73e+07. What is the difference between the highest and the lowest Net Disbursements (current US$) in 2006?
Provide a short and direct response. 2.23e+07. What is the difference between the highest and the lowest Net Disbursements (current US$) of 2007?
Offer a very short reply. 6.84e+07. What is the difference between the highest and the lowest Net Disbursements (current US$) in 2008?
Keep it short and to the point. 4.25e+07. 